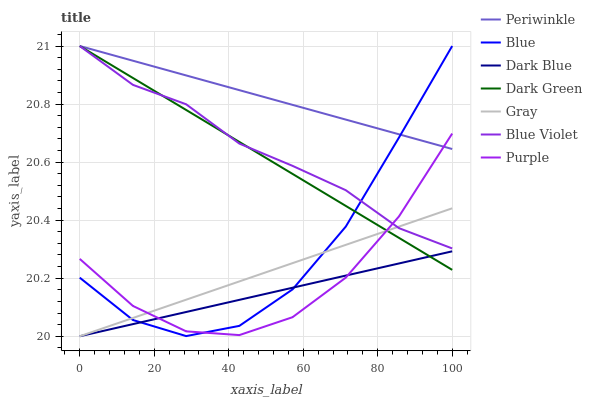Does Gray have the minimum area under the curve?
Answer yes or no. No. Does Gray have the maximum area under the curve?
Answer yes or no. No. Is Gray the smoothest?
Answer yes or no. No. Is Gray the roughest?
Answer yes or no. No. Does Purple have the lowest value?
Answer yes or no. No. Does Gray have the highest value?
Answer yes or no. No. Is Dark Blue less than Periwinkle?
Answer yes or no. Yes. Is Periwinkle greater than Dark Blue?
Answer yes or no. Yes. Does Dark Blue intersect Periwinkle?
Answer yes or no. No. 